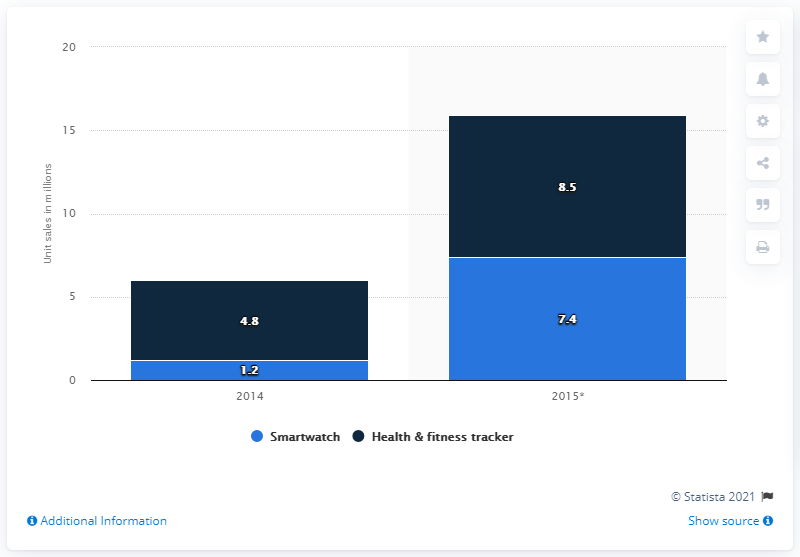Highlight a few significant elements in this photo. It is predicted that 7.4 units of smartwatches will be sold in North America in 2015. 